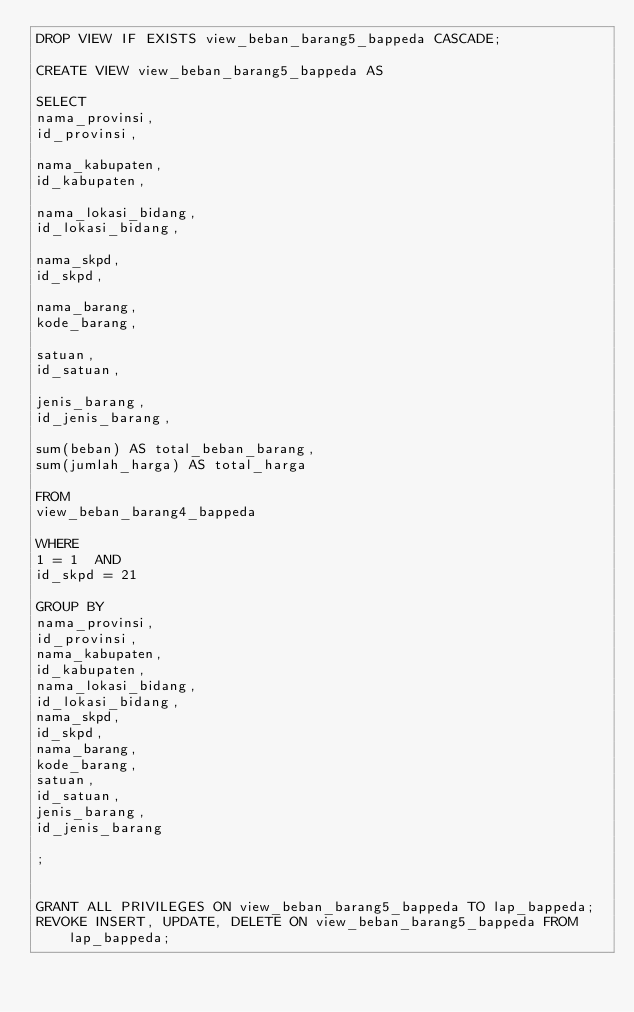Convert code to text. <code><loc_0><loc_0><loc_500><loc_500><_SQL_>DROP VIEW IF EXISTS view_beban_barang5_bappeda CASCADE;

CREATE VIEW view_beban_barang5_bappeda AS

SELECT
nama_provinsi,
id_provinsi,

nama_kabupaten,
id_kabupaten,

nama_lokasi_bidang,
id_lokasi_bidang,

nama_skpd,
id_skpd,

nama_barang,
kode_barang,

satuan,
id_satuan,

jenis_barang,
id_jenis_barang,

sum(beban) AS total_beban_barang,
sum(jumlah_harga) AS total_harga

FROM
view_beban_barang4_bappeda

WHERE
1 = 1  AND
id_skpd = 21

GROUP BY
nama_provinsi,
id_provinsi,
nama_kabupaten,
id_kabupaten,
nama_lokasi_bidang,
id_lokasi_bidang,
nama_skpd,
id_skpd,
nama_barang,
kode_barang,
satuan,
id_satuan,
jenis_barang,
id_jenis_barang

;


GRANT ALL PRIVILEGES ON view_beban_barang5_bappeda TO lap_bappeda;
REVOKE INSERT, UPDATE, DELETE ON view_beban_barang5_bappeda FROM lap_bappeda;
</code> 